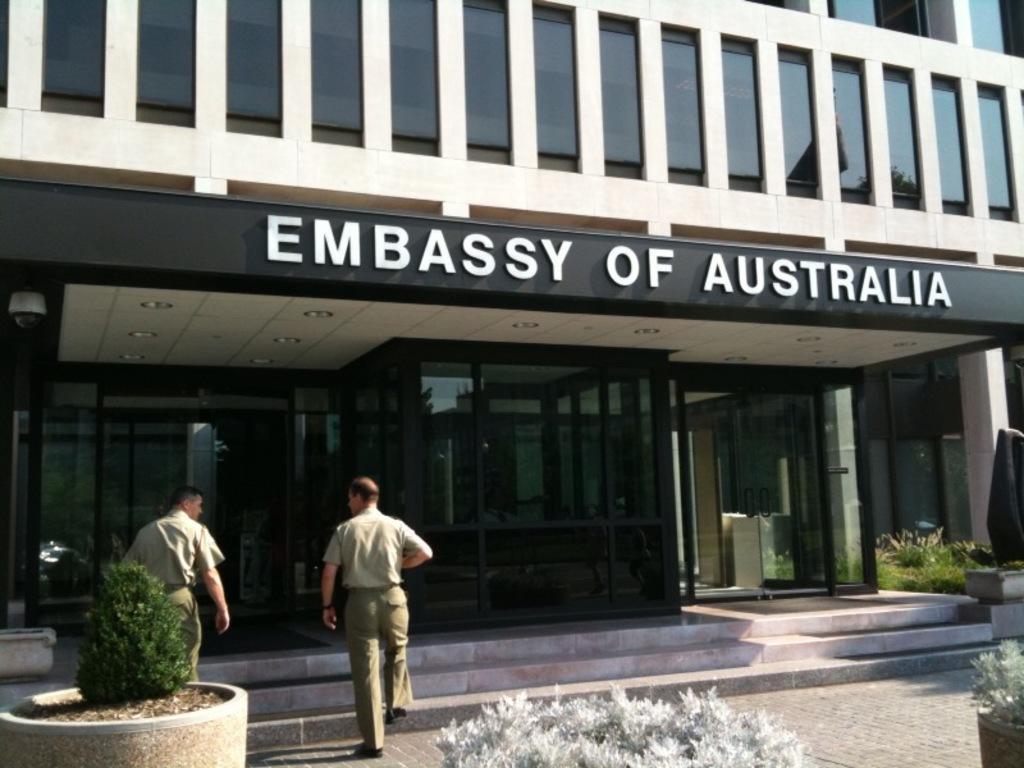Please provide a concise description of this image. In this image we can see a building, name board, house plants, bushes and persons walking on the floor. 